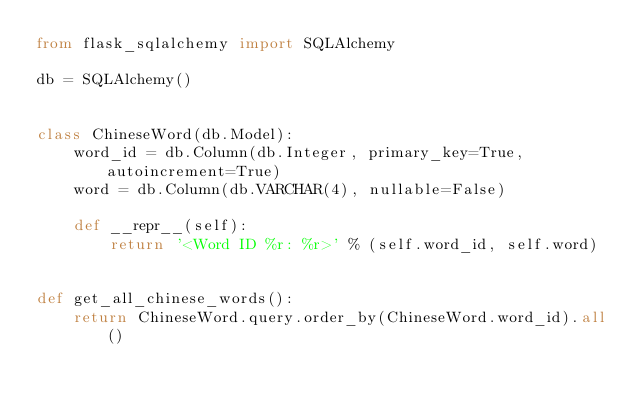Convert code to text. <code><loc_0><loc_0><loc_500><loc_500><_Python_>from flask_sqlalchemy import SQLAlchemy

db = SQLAlchemy()


class ChineseWord(db.Model):
    word_id = db.Column(db.Integer, primary_key=True, autoincrement=True)
    word = db.Column(db.VARCHAR(4), nullable=False)

    def __repr__(self):
        return '<Word ID %r: %r>' % (self.word_id, self.word)


def get_all_chinese_words():
    return ChineseWord.query.order_by(ChineseWord.word_id).all()
</code> 